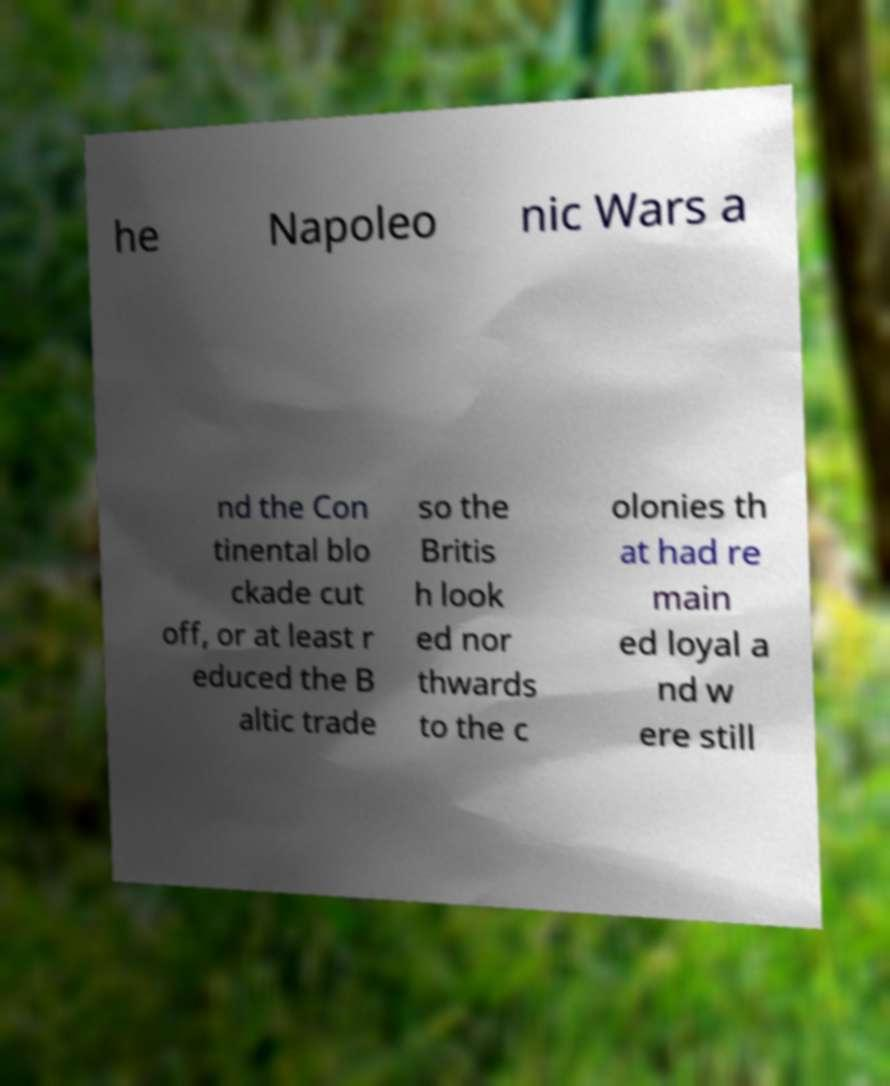What messages or text are displayed in this image? I need them in a readable, typed format. he Napoleo nic Wars a nd the Con tinental blo ckade cut off, or at least r educed the B altic trade so the Britis h look ed nor thwards to the c olonies th at had re main ed loyal a nd w ere still 